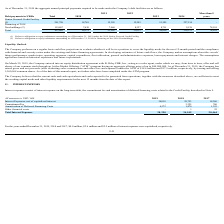From Nordic American Tankers Limited's financial document, What are the respective interest expenses capitalised in the years ended December 31, 2019 and 2018? The document shows two values: $0.0 million and $2.6 million. From the document: "ed December 31, 2019, 2018 and 2017, $0.0 million, $2.6 million and $2.5 million of interest expenses were capitalized, respectively. the years ended ..." Also, What are the respective interest expenses capitalised in the years ended December 31, 2018 and 2017? The document shows two values: $2.6 million and $2.5 million. From the document: "ed December 31, 2019, 2018 and 2017, $0.0 million, $2.6 million and $2.5 million of interest expenses were capitalized, respectively. 019, 2018 and 20..." Also, What are the respective interest expenses net of capitalised interest in 2018 and 2019? The document shows two values: 29,753 and 34,018 (in thousands). From the document: "Interest Expenses, net of capitalized interest 34,018 29,753 18,286 rest Expenses, net of capitalized interest 34,018 29,753 18,286..." Also, can you calculate: What is the percentage change in the interest expense, net of capitalised interest between 2017 and 2018? To answer this question, I need to perform calculations using the financial data. The calculation is: (29,753 - 18,286)/18,286 , which equals 62.71 (percentage). This is based on the information: "rest Expenses, net of capitalized interest 34,018 29,753 18,286 penses, net of capitalized interest 34,018 29,753 18,286..." The key data points involved are: 18,286, 29,753. Also, can you calculate: What is the percentage change in the interest expense, net of capitalised interest between 2018 and 2019? To answer this question, I need to perform calculations using the financial data. The calculation is: (34,018 - 29,753)/29,753 , which equals 14.33 (percentage). This is based on the information: "Interest Expenses, net of capitalized interest 34,018 29,753 18,286 rest Expenses, net of capitalized interest 34,018 29,753 18,286..." The key data points involved are: 29,753, 34,018. Also, can you calculate: What is the percentage change in the total interest expense between 2018 and 2019? To answer this question, I need to perform calculations using the financial data. The calculation is: (38,390 - 34,549)/34,549 , which equals 11.12 (percentage). This is based on the information: "Total Interest Expenses 38,390 34,549 20,464 Total Interest Expenses 38,390 34,549 20,464..." The key data points involved are: 34,549, 38,390. 